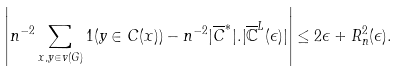Convert formula to latex. <formula><loc_0><loc_0><loc_500><loc_500>\left | n ^ { - 2 } \sum _ { x , y \in v ( G ) } 1 ( y \in C ( x ) ) - n ^ { - 2 } | \overline { C } ^ { * } | . | \overline { \mathbb { C } } ^ { L } ( \epsilon ) | \right | \leq 2 \epsilon + R _ { n } ^ { 2 } ( \epsilon ) .</formula> 